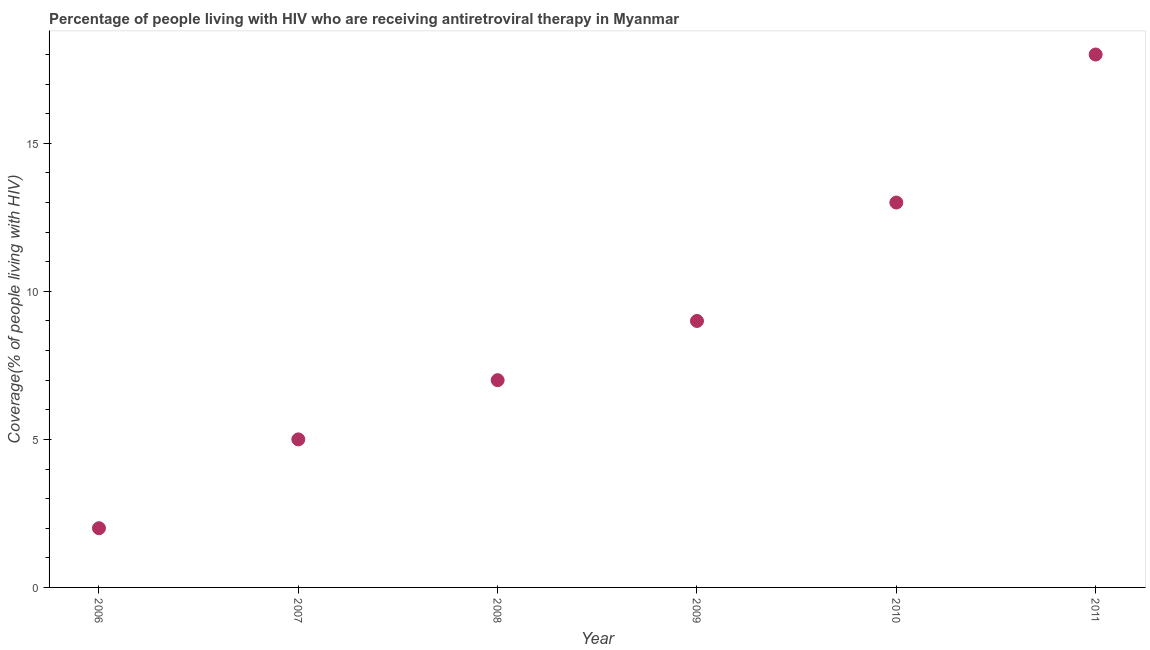What is the antiretroviral therapy coverage in 2008?
Provide a short and direct response. 7. Across all years, what is the maximum antiretroviral therapy coverage?
Offer a very short reply. 18. Across all years, what is the minimum antiretroviral therapy coverage?
Provide a short and direct response. 2. In which year was the antiretroviral therapy coverage minimum?
Your response must be concise. 2006. What is the sum of the antiretroviral therapy coverage?
Your answer should be very brief. 54. What is the difference between the antiretroviral therapy coverage in 2006 and 2007?
Your answer should be compact. -3. What is the average antiretroviral therapy coverage per year?
Provide a succinct answer. 9. Do a majority of the years between 2010 and 2008 (inclusive) have antiretroviral therapy coverage greater than 9 %?
Your response must be concise. No. What is the ratio of the antiretroviral therapy coverage in 2008 to that in 2009?
Make the answer very short. 0.78. Is the sum of the antiretroviral therapy coverage in 2007 and 2009 greater than the maximum antiretroviral therapy coverage across all years?
Ensure brevity in your answer.  No. What is the difference between the highest and the lowest antiretroviral therapy coverage?
Provide a short and direct response. 16. Does the graph contain grids?
Offer a very short reply. No. What is the title of the graph?
Ensure brevity in your answer.  Percentage of people living with HIV who are receiving antiretroviral therapy in Myanmar. What is the label or title of the Y-axis?
Make the answer very short. Coverage(% of people living with HIV). What is the Coverage(% of people living with HIV) in 2010?
Offer a terse response. 13. What is the difference between the Coverage(% of people living with HIV) in 2006 and 2007?
Provide a short and direct response. -3. What is the difference between the Coverage(% of people living with HIV) in 2006 and 2009?
Provide a short and direct response. -7. What is the difference between the Coverage(% of people living with HIV) in 2006 and 2010?
Keep it short and to the point. -11. What is the difference between the Coverage(% of people living with HIV) in 2007 and 2008?
Offer a terse response. -2. What is the difference between the Coverage(% of people living with HIV) in 2007 and 2010?
Offer a terse response. -8. What is the difference between the Coverage(% of people living with HIV) in 2008 and 2009?
Your response must be concise. -2. What is the difference between the Coverage(% of people living with HIV) in 2008 and 2010?
Offer a very short reply. -6. What is the difference between the Coverage(% of people living with HIV) in 2008 and 2011?
Keep it short and to the point. -11. What is the difference between the Coverage(% of people living with HIV) in 2009 and 2011?
Your answer should be very brief. -9. What is the ratio of the Coverage(% of people living with HIV) in 2006 to that in 2008?
Your answer should be compact. 0.29. What is the ratio of the Coverage(% of people living with HIV) in 2006 to that in 2009?
Your response must be concise. 0.22. What is the ratio of the Coverage(% of people living with HIV) in 2006 to that in 2010?
Ensure brevity in your answer.  0.15. What is the ratio of the Coverage(% of people living with HIV) in 2006 to that in 2011?
Your response must be concise. 0.11. What is the ratio of the Coverage(% of people living with HIV) in 2007 to that in 2008?
Keep it short and to the point. 0.71. What is the ratio of the Coverage(% of people living with HIV) in 2007 to that in 2009?
Keep it short and to the point. 0.56. What is the ratio of the Coverage(% of people living with HIV) in 2007 to that in 2010?
Your answer should be very brief. 0.39. What is the ratio of the Coverage(% of people living with HIV) in 2007 to that in 2011?
Ensure brevity in your answer.  0.28. What is the ratio of the Coverage(% of people living with HIV) in 2008 to that in 2009?
Give a very brief answer. 0.78. What is the ratio of the Coverage(% of people living with HIV) in 2008 to that in 2010?
Provide a short and direct response. 0.54. What is the ratio of the Coverage(% of people living with HIV) in 2008 to that in 2011?
Your response must be concise. 0.39. What is the ratio of the Coverage(% of people living with HIV) in 2009 to that in 2010?
Provide a succinct answer. 0.69. What is the ratio of the Coverage(% of people living with HIV) in 2009 to that in 2011?
Give a very brief answer. 0.5. What is the ratio of the Coverage(% of people living with HIV) in 2010 to that in 2011?
Offer a very short reply. 0.72. 